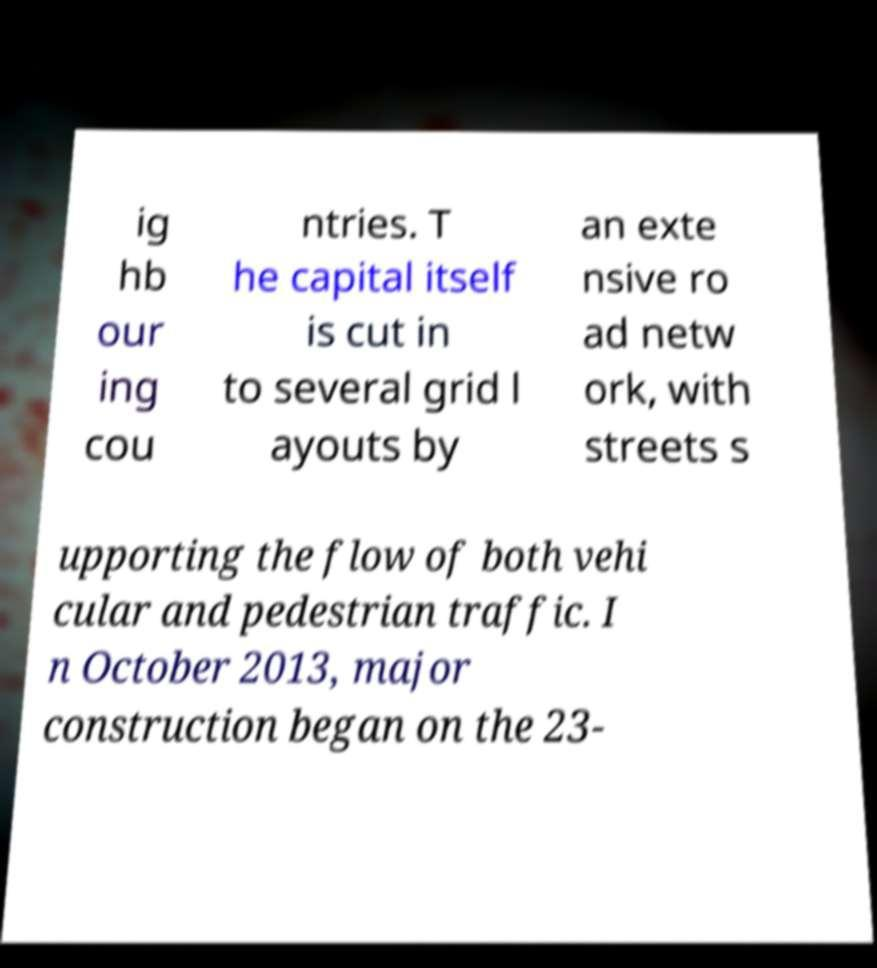There's text embedded in this image that I need extracted. Can you transcribe it verbatim? ig hb our ing cou ntries. T he capital itself is cut in to several grid l ayouts by an exte nsive ro ad netw ork, with streets s upporting the flow of both vehi cular and pedestrian traffic. I n October 2013, major construction began on the 23- 